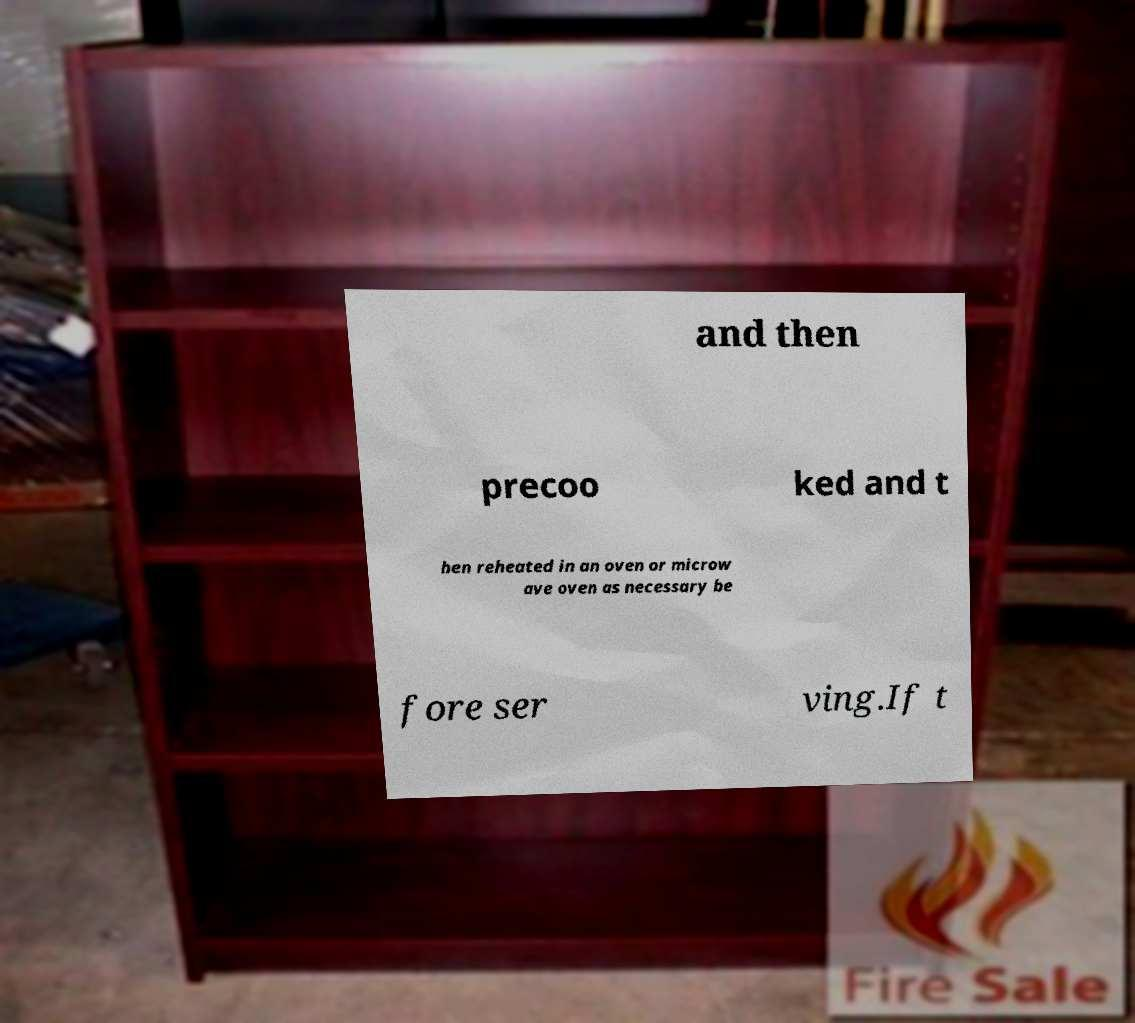Can you read and provide the text displayed in the image?This photo seems to have some interesting text. Can you extract and type it out for me? and then precoo ked and t hen reheated in an oven or microw ave oven as necessary be fore ser ving.If t 